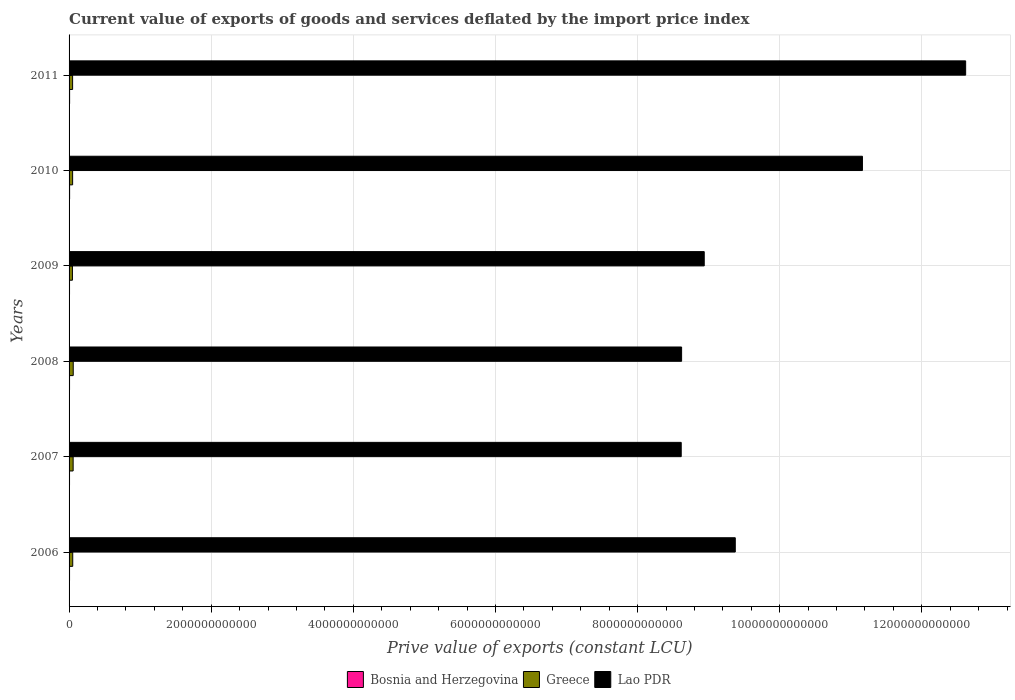How many different coloured bars are there?
Provide a short and direct response. 3. Are the number of bars on each tick of the Y-axis equal?
Offer a terse response. Yes. How many bars are there on the 6th tick from the bottom?
Offer a very short reply. 3. What is the label of the 6th group of bars from the top?
Your answer should be compact. 2006. What is the prive value of exports in Greece in 2011?
Your answer should be very brief. 4.97e+1. Across all years, what is the maximum prive value of exports in Greece?
Your answer should be compact. 5.86e+1. Across all years, what is the minimum prive value of exports in Lao PDR?
Offer a terse response. 8.61e+12. In which year was the prive value of exports in Bosnia and Herzegovina maximum?
Give a very brief answer. 2011. What is the total prive value of exports in Lao PDR in the graph?
Your answer should be compact. 5.93e+13. What is the difference between the prive value of exports in Lao PDR in 2006 and that in 2010?
Provide a succinct answer. -1.79e+12. What is the difference between the prive value of exports in Bosnia and Herzegovina in 2011 and the prive value of exports in Lao PDR in 2008?
Your answer should be very brief. -8.61e+12. What is the average prive value of exports in Lao PDR per year?
Provide a short and direct response. 9.89e+12. In the year 2011, what is the difference between the prive value of exports in Greece and prive value of exports in Lao PDR?
Provide a short and direct response. -1.26e+13. What is the ratio of the prive value of exports in Bosnia and Herzegovina in 2006 to that in 2011?
Offer a terse response. 0.87. Is the prive value of exports in Bosnia and Herzegovina in 2006 less than that in 2007?
Provide a succinct answer. No. Is the difference between the prive value of exports in Greece in 2008 and 2011 greater than the difference between the prive value of exports in Lao PDR in 2008 and 2011?
Give a very brief answer. Yes. What is the difference between the highest and the second highest prive value of exports in Bosnia and Herzegovina?
Keep it short and to the point. 1.52e+08. What is the difference between the highest and the lowest prive value of exports in Bosnia and Herzegovina?
Offer a terse response. 1.23e+09. In how many years, is the prive value of exports in Greece greater than the average prive value of exports in Greece taken over all years?
Your answer should be very brief. 2. Is the sum of the prive value of exports in Greece in 2008 and 2009 greater than the maximum prive value of exports in Lao PDR across all years?
Provide a short and direct response. No. What does the 3rd bar from the top in 2010 represents?
Make the answer very short. Bosnia and Herzegovina. What does the 2nd bar from the bottom in 2006 represents?
Provide a succinct answer. Greece. How many bars are there?
Offer a very short reply. 18. How many years are there in the graph?
Ensure brevity in your answer.  6. What is the difference between two consecutive major ticks on the X-axis?
Offer a very short reply. 2.00e+12. Are the values on the major ticks of X-axis written in scientific E-notation?
Your answer should be very brief. No. Does the graph contain any zero values?
Your answer should be very brief. No. Where does the legend appear in the graph?
Provide a short and direct response. Bottom center. How many legend labels are there?
Keep it short and to the point. 3. What is the title of the graph?
Your answer should be compact. Current value of exports of goods and services deflated by the import price index. What is the label or title of the X-axis?
Make the answer very short. Prive value of exports (constant LCU). What is the label or title of the Y-axis?
Your response must be concise. Years. What is the Prive value of exports (constant LCU) in Bosnia and Herzegovina in 2006?
Offer a very short reply. 6.66e+09. What is the Prive value of exports (constant LCU) of Greece in 2006?
Your answer should be compact. 5.16e+1. What is the Prive value of exports (constant LCU) in Lao PDR in 2006?
Keep it short and to the point. 9.37e+12. What is the Prive value of exports (constant LCU) in Bosnia and Herzegovina in 2007?
Provide a succinct answer. 6.46e+09. What is the Prive value of exports (constant LCU) in Greece in 2007?
Offer a terse response. 5.73e+1. What is the Prive value of exports (constant LCU) in Lao PDR in 2007?
Offer a very short reply. 8.61e+12. What is the Prive value of exports (constant LCU) of Bosnia and Herzegovina in 2008?
Ensure brevity in your answer.  6.71e+09. What is the Prive value of exports (constant LCU) in Greece in 2008?
Offer a very short reply. 5.86e+1. What is the Prive value of exports (constant LCU) in Lao PDR in 2008?
Provide a short and direct response. 8.62e+12. What is the Prive value of exports (constant LCU) in Bosnia and Herzegovina in 2009?
Give a very brief answer. 6.51e+09. What is the Prive value of exports (constant LCU) of Greece in 2009?
Offer a very short reply. 4.75e+1. What is the Prive value of exports (constant LCU) of Lao PDR in 2009?
Provide a short and direct response. 8.94e+12. What is the Prive value of exports (constant LCU) in Bosnia and Herzegovina in 2010?
Your answer should be very brief. 7.53e+09. What is the Prive value of exports (constant LCU) of Greece in 2010?
Offer a very short reply. 5.00e+1. What is the Prive value of exports (constant LCU) of Lao PDR in 2010?
Give a very brief answer. 1.12e+13. What is the Prive value of exports (constant LCU) in Bosnia and Herzegovina in 2011?
Make the answer very short. 7.68e+09. What is the Prive value of exports (constant LCU) in Greece in 2011?
Offer a very short reply. 4.97e+1. What is the Prive value of exports (constant LCU) in Lao PDR in 2011?
Your response must be concise. 1.26e+13. Across all years, what is the maximum Prive value of exports (constant LCU) in Bosnia and Herzegovina?
Provide a short and direct response. 7.68e+09. Across all years, what is the maximum Prive value of exports (constant LCU) of Greece?
Make the answer very short. 5.86e+1. Across all years, what is the maximum Prive value of exports (constant LCU) of Lao PDR?
Your answer should be very brief. 1.26e+13. Across all years, what is the minimum Prive value of exports (constant LCU) of Bosnia and Herzegovina?
Keep it short and to the point. 6.46e+09. Across all years, what is the minimum Prive value of exports (constant LCU) of Greece?
Your answer should be compact. 4.75e+1. Across all years, what is the minimum Prive value of exports (constant LCU) of Lao PDR?
Your answer should be compact. 8.61e+12. What is the total Prive value of exports (constant LCU) of Bosnia and Herzegovina in the graph?
Offer a very short reply. 4.16e+1. What is the total Prive value of exports (constant LCU) of Greece in the graph?
Your answer should be compact. 3.15e+11. What is the total Prive value of exports (constant LCU) of Lao PDR in the graph?
Your answer should be very brief. 5.93e+13. What is the difference between the Prive value of exports (constant LCU) in Bosnia and Herzegovina in 2006 and that in 2007?
Make the answer very short. 2.02e+08. What is the difference between the Prive value of exports (constant LCU) of Greece in 2006 and that in 2007?
Keep it short and to the point. -5.76e+09. What is the difference between the Prive value of exports (constant LCU) in Lao PDR in 2006 and that in 2007?
Provide a short and direct response. 7.61e+11. What is the difference between the Prive value of exports (constant LCU) of Bosnia and Herzegovina in 2006 and that in 2008?
Make the answer very short. -4.52e+07. What is the difference between the Prive value of exports (constant LCU) in Greece in 2006 and that in 2008?
Give a very brief answer. -7.07e+09. What is the difference between the Prive value of exports (constant LCU) of Lao PDR in 2006 and that in 2008?
Your response must be concise. 7.55e+11. What is the difference between the Prive value of exports (constant LCU) of Bosnia and Herzegovina in 2006 and that in 2009?
Your answer should be compact. 1.49e+08. What is the difference between the Prive value of exports (constant LCU) in Greece in 2006 and that in 2009?
Make the answer very short. 4.11e+09. What is the difference between the Prive value of exports (constant LCU) of Lao PDR in 2006 and that in 2009?
Provide a succinct answer. 4.37e+11. What is the difference between the Prive value of exports (constant LCU) of Bosnia and Herzegovina in 2006 and that in 2010?
Keep it short and to the point. -8.71e+08. What is the difference between the Prive value of exports (constant LCU) in Greece in 2006 and that in 2010?
Make the answer very short. 1.62e+09. What is the difference between the Prive value of exports (constant LCU) of Lao PDR in 2006 and that in 2010?
Keep it short and to the point. -1.79e+12. What is the difference between the Prive value of exports (constant LCU) in Bosnia and Herzegovina in 2006 and that in 2011?
Give a very brief answer. -1.02e+09. What is the difference between the Prive value of exports (constant LCU) in Greece in 2006 and that in 2011?
Keep it short and to the point. 1.87e+09. What is the difference between the Prive value of exports (constant LCU) of Lao PDR in 2006 and that in 2011?
Your answer should be very brief. -3.24e+12. What is the difference between the Prive value of exports (constant LCU) in Bosnia and Herzegovina in 2007 and that in 2008?
Offer a very short reply. -2.48e+08. What is the difference between the Prive value of exports (constant LCU) of Greece in 2007 and that in 2008?
Ensure brevity in your answer.  -1.31e+09. What is the difference between the Prive value of exports (constant LCU) of Lao PDR in 2007 and that in 2008?
Ensure brevity in your answer.  -5.55e+09. What is the difference between the Prive value of exports (constant LCU) of Bosnia and Herzegovina in 2007 and that in 2009?
Ensure brevity in your answer.  -5.35e+07. What is the difference between the Prive value of exports (constant LCU) of Greece in 2007 and that in 2009?
Give a very brief answer. 9.87e+09. What is the difference between the Prive value of exports (constant LCU) in Lao PDR in 2007 and that in 2009?
Your response must be concise. -3.24e+11. What is the difference between the Prive value of exports (constant LCU) in Bosnia and Herzegovina in 2007 and that in 2010?
Provide a short and direct response. -1.07e+09. What is the difference between the Prive value of exports (constant LCU) of Greece in 2007 and that in 2010?
Offer a terse response. 7.38e+09. What is the difference between the Prive value of exports (constant LCU) in Lao PDR in 2007 and that in 2010?
Provide a short and direct response. -2.55e+12. What is the difference between the Prive value of exports (constant LCU) in Bosnia and Herzegovina in 2007 and that in 2011?
Offer a terse response. -1.23e+09. What is the difference between the Prive value of exports (constant LCU) of Greece in 2007 and that in 2011?
Make the answer very short. 7.63e+09. What is the difference between the Prive value of exports (constant LCU) in Lao PDR in 2007 and that in 2011?
Ensure brevity in your answer.  -4.00e+12. What is the difference between the Prive value of exports (constant LCU) in Bosnia and Herzegovina in 2008 and that in 2009?
Make the answer very short. 1.94e+08. What is the difference between the Prive value of exports (constant LCU) in Greece in 2008 and that in 2009?
Give a very brief answer. 1.12e+1. What is the difference between the Prive value of exports (constant LCU) of Lao PDR in 2008 and that in 2009?
Make the answer very short. -3.18e+11. What is the difference between the Prive value of exports (constant LCU) in Bosnia and Herzegovina in 2008 and that in 2010?
Your response must be concise. -8.26e+08. What is the difference between the Prive value of exports (constant LCU) of Greece in 2008 and that in 2010?
Provide a succinct answer. 8.69e+09. What is the difference between the Prive value of exports (constant LCU) in Lao PDR in 2008 and that in 2010?
Your answer should be very brief. -2.54e+12. What is the difference between the Prive value of exports (constant LCU) of Bosnia and Herzegovina in 2008 and that in 2011?
Give a very brief answer. -9.78e+08. What is the difference between the Prive value of exports (constant LCU) of Greece in 2008 and that in 2011?
Offer a terse response. 8.95e+09. What is the difference between the Prive value of exports (constant LCU) of Lao PDR in 2008 and that in 2011?
Ensure brevity in your answer.  -4.00e+12. What is the difference between the Prive value of exports (constant LCU) in Bosnia and Herzegovina in 2009 and that in 2010?
Your response must be concise. -1.02e+09. What is the difference between the Prive value of exports (constant LCU) of Greece in 2009 and that in 2010?
Your answer should be compact. -2.49e+09. What is the difference between the Prive value of exports (constant LCU) in Lao PDR in 2009 and that in 2010?
Your answer should be very brief. -2.23e+12. What is the difference between the Prive value of exports (constant LCU) in Bosnia and Herzegovina in 2009 and that in 2011?
Offer a very short reply. -1.17e+09. What is the difference between the Prive value of exports (constant LCU) in Greece in 2009 and that in 2011?
Provide a succinct answer. -2.24e+09. What is the difference between the Prive value of exports (constant LCU) of Lao PDR in 2009 and that in 2011?
Make the answer very short. -3.68e+12. What is the difference between the Prive value of exports (constant LCU) of Bosnia and Herzegovina in 2010 and that in 2011?
Provide a short and direct response. -1.52e+08. What is the difference between the Prive value of exports (constant LCU) in Greece in 2010 and that in 2011?
Make the answer very short. 2.53e+08. What is the difference between the Prive value of exports (constant LCU) in Lao PDR in 2010 and that in 2011?
Ensure brevity in your answer.  -1.45e+12. What is the difference between the Prive value of exports (constant LCU) in Bosnia and Herzegovina in 2006 and the Prive value of exports (constant LCU) in Greece in 2007?
Keep it short and to the point. -5.07e+1. What is the difference between the Prive value of exports (constant LCU) of Bosnia and Herzegovina in 2006 and the Prive value of exports (constant LCU) of Lao PDR in 2007?
Ensure brevity in your answer.  -8.61e+12. What is the difference between the Prive value of exports (constant LCU) of Greece in 2006 and the Prive value of exports (constant LCU) of Lao PDR in 2007?
Provide a short and direct response. -8.56e+12. What is the difference between the Prive value of exports (constant LCU) in Bosnia and Herzegovina in 2006 and the Prive value of exports (constant LCU) in Greece in 2008?
Give a very brief answer. -5.20e+1. What is the difference between the Prive value of exports (constant LCU) in Bosnia and Herzegovina in 2006 and the Prive value of exports (constant LCU) in Lao PDR in 2008?
Your response must be concise. -8.61e+12. What is the difference between the Prive value of exports (constant LCU) of Greece in 2006 and the Prive value of exports (constant LCU) of Lao PDR in 2008?
Provide a succinct answer. -8.57e+12. What is the difference between the Prive value of exports (constant LCU) of Bosnia and Herzegovina in 2006 and the Prive value of exports (constant LCU) of Greece in 2009?
Make the answer very short. -4.08e+1. What is the difference between the Prive value of exports (constant LCU) of Bosnia and Herzegovina in 2006 and the Prive value of exports (constant LCU) of Lao PDR in 2009?
Provide a short and direct response. -8.93e+12. What is the difference between the Prive value of exports (constant LCU) of Greece in 2006 and the Prive value of exports (constant LCU) of Lao PDR in 2009?
Give a very brief answer. -8.89e+12. What is the difference between the Prive value of exports (constant LCU) in Bosnia and Herzegovina in 2006 and the Prive value of exports (constant LCU) in Greece in 2010?
Provide a short and direct response. -4.33e+1. What is the difference between the Prive value of exports (constant LCU) in Bosnia and Herzegovina in 2006 and the Prive value of exports (constant LCU) in Lao PDR in 2010?
Make the answer very short. -1.12e+13. What is the difference between the Prive value of exports (constant LCU) in Greece in 2006 and the Prive value of exports (constant LCU) in Lao PDR in 2010?
Offer a very short reply. -1.11e+13. What is the difference between the Prive value of exports (constant LCU) in Bosnia and Herzegovina in 2006 and the Prive value of exports (constant LCU) in Greece in 2011?
Your response must be concise. -4.30e+1. What is the difference between the Prive value of exports (constant LCU) of Bosnia and Herzegovina in 2006 and the Prive value of exports (constant LCU) of Lao PDR in 2011?
Your response must be concise. -1.26e+13. What is the difference between the Prive value of exports (constant LCU) of Greece in 2006 and the Prive value of exports (constant LCU) of Lao PDR in 2011?
Your answer should be compact. -1.26e+13. What is the difference between the Prive value of exports (constant LCU) in Bosnia and Herzegovina in 2007 and the Prive value of exports (constant LCU) in Greece in 2008?
Make the answer very short. -5.22e+1. What is the difference between the Prive value of exports (constant LCU) in Bosnia and Herzegovina in 2007 and the Prive value of exports (constant LCU) in Lao PDR in 2008?
Ensure brevity in your answer.  -8.61e+12. What is the difference between the Prive value of exports (constant LCU) in Greece in 2007 and the Prive value of exports (constant LCU) in Lao PDR in 2008?
Your response must be concise. -8.56e+12. What is the difference between the Prive value of exports (constant LCU) of Bosnia and Herzegovina in 2007 and the Prive value of exports (constant LCU) of Greece in 2009?
Provide a succinct answer. -4.10e+1. What is the difference between the Prive value of exports (constant LCU) in Bosnia and Herzegovina in 2007 and the Prive value of exports (constant LCU) in Lao PDR in 2009?
Keep it short and to the point. -8.93e+12. What is the difference between the Prive value of exports (constant LCU) in Greece in 2007 and the Prive value of exports (constant LCU) in Lao PDR in 2009?
Offer a very short reply. -8.88e+12. What is the difference between the Prive value of exports (constant LCU) in Bosnia and Herzegovina in 2007 and the Prive value of exports (constant LCU) in Greece in 2010?
Provide a short and direct response. -4.35e+1. What is the difference between the Prive value of exports (constant LCU) of Bosnia and Herzegovina in 2007 and the Prive value of exports (constant LCU) of Lao PDR in 2010?
Make the answer very short. -1.12e+13. What is the difference between the Prive value of exports (constant LCU) in Greece in 2007 and the Prive value of exports (constant LCU) in Lao PDR in 2010?
Provide a short and direct response. -1.11e+13. What is the difference between the Prive value of exports (constant LCU) in Bosnia and Herzegovina in 2007 and the Prive value of exports (constant LCU) in Greece in 2011?
Offer a terse response. -4.32e+1. What is the difference between the Prive value of exports (constant LCU) in Bosnia and Herzegovina in 2007 and the Prive value of exports (constant LCU) in Lao PDR in 2011?
Give a very brief answer. -1.26e+13. What is the difference between the Prive value of exports (constant LCU) of Greece in 2007 and the Prive value of exports (constant LCU) of Lao PDR in 2011?
Your answer should be very brief. -1.26e+13. What is the difference between the Prive value of exports (constant LCU) of Bosnia and Herzegovina in 2008 and the Prive value of exports (constant LCU) of Greece in 2009?
Provide a succinct answer. -4.08e+1. What is the difference between the Prive value of exports (constant LCU) of Bosnia and Herzegovina in 2008 and the Prive value of exports (constant LCU) of Lao PDR in 2009?
Keep it short and to the point. -8.93e+12. What is the difference between the Prive value of exports (constant LCU) of Greece in 2008 and the Prive value of exports (constant LCU) of Lao PDR in 2009?
Your answer should be compact. -8.88e+12. What is the difference between the Prive value of exports (constant LCU) in Bosnia and Herzegovina in 2008 and the Prive value of exports (constant LCU) in Greece in 2010?
Provide a succinct answer. -4.33e+1. What is the difference between the Prive value of exports (constant LCU) of Bosnia and Herzegovina in 2008 and the Prive value of exports (constant LCU) of Lao PDR in 2010?
Offer a terse response. -1.12e+13. What is the difference between the Prive value of exports (constant LCU) of Greece in 2008 and the Prive value of exports (constant LCU) of Lao PDR in 2010?
Your answer should be compact. -1.11e+13. What is the difference between the Prive value of exports (constant LCU) in Bosnia and Herzegovina in 2008 and the Prive value of exports (constant LCU) in Greece in 2011?
Your response must be concise. -4.30e+1. What is the difference between the Prive value of exports (constant LCU) of Bosnia and Herzegovina in 2008 and the Prive value of exports (constant LCU) of Lao PDR in 2011?
Offer a very short reply. -1.26e+13. What is the difference between the Prive value of exports (constant LCU) of Greece in 2008 and the Prive value of exports (constant LCU) of Lao PDR in 2011?
Offer a very short reply. -1.26e+13. What is the difference between the Prive value of exports (constant LCU) of Bosnia and Herzegovina in 2009 and the Prive value of exports (constant LCU) of Greece in 2010?
Keep it short and to the point. -4.34e+1. What is the difference between the Prive value of exports (constant LCU) of Bosnia and Herzegovina in 2009 and the Prive value of exports (constant LCU) of Lao PDR in 2010?
Offer a very short reply. -1.12e+13. What is the difference between the Prive value of exports (constant LCU) in Greece in 2009 and the Prive value of exports (constant LCU) in Lao PDR in 2010?
Offer a terse response. -1.11e+13. What is the difference between the Prive value of exports (constant LCU) of Bosnia and Herzegovina in 2009 and the Prive value of exports (constant LCU) of Greece in 2011?
Make the answer very short. -4.32e+1. What is the difference between the Prive value of exports (constant LCU) of Bosnia and Herzegovina in 2009 and the Prive value of exports (constant LCU) of Lao PDR in 2011?
Make the answer very short. -1.26e+13. What is the difference between the Prive value of exports (constant LCU) of Greece in 2009 and the Prive value of exports (constant LCU) of Lao PDR in 2011?
Make the answer very short. -1.26e+13. What is the difference between the Prive value of exports (constant LCU) in Bosnia and Herzegovina in 2010 and the Prive value of exports (constant LCU) in Greece in 2011?
Offer a terse response. -4.22e+1. What is the difference between the Prive value of exports (constant LCU) of Bosnia and Herzegovina in 2010 and the Prive value of exports (constant LCU) of Lao PDR in 2011?
Make the answer very short. -1.26e+13. What is the difference between the Prive value of exports (constant LCU) of Greece in 2010 and the Prive value of exports (constant LCU) of Lao PDR in 2011?
Offer a very short reply. -1.26e+13. What is the average Prive value of exports (constant LCU) in Bosnia and Herzegovina per year?
Keep it short and to the point. 6.93e+09. What is the average Prive value of exports (constant LCU) in Greece per year?
Your answer should be compact. 5.24e+1. What is the average Prive value of exports (constant LCU) in Lao PDR per year?
Keep it short and to the point. 9.89e+12. In the year 2006, what is the difference between the Prive value of exports (constant LCU) in Bosnia and Herzegovina and Prive value of exports (constant LCU) in Greece?
Ensure brevity in your answer.  -4.49e+1. In the year 2006, what is the difference between the Prive value of exports (constant LCU) in Bosnia and Herzegovina and Prive value of exports (constant LCU) in Lao PDR?
Your response must be concise. -9.37e+12. In the year 2006, what is the difference between the Prive value of exports (constant LCU) of Greece and Prive value of exports (constant LCU) of Lao PDR?
Provide a short and direct response. -9.32e+12. In the year 2007, what is the difference between the Prive value of exports (constant LCU) in Bosnia and Herzegovina and Prive value of exports (constant LCU) in Greece?
Make the answer very short. -5.09e+1. In the year 2007, what is the difference between the Prive value of exports (constant LCU) of Bosnia and Herzegovina and Prive value of exports (constant LCU) of Lao PDR?
Keep it short and to the point. -8.61e+12. In the year 2007, what is the difference between the Prive value of exports (constant LCU) in Greece and Prive value of exports (constant LCU) in Lao PDR?
Provide a short and direct response. -8.56e+12. In the year 2008, what is the difference between the Prive value of exports (constant LCU) in Bosnia and Herzegovina and Prive value of exports (constant LCU) in Greece?
Your response must be concise. -5.19e+1. In the year 2008, what is the difference between the Prive value of exports (constant LCU) in Bosnia and Herzegovina and Prive value of exports (constant LCU) in Lao PDR?
Keep it short and to the point. -8.61e+12. In the year 2008, what is the difference between the Prive value of exports (constant LCU) of Greece and Prive value of exports (constant LCU) of Lao PDR?
Offer a very short reply. -8.56e+12. In the year 2009, what is the difference between the Prive value of exports (constant LCU) of Bosnia and Herzegovina and Prive value of exports (constant LCU) of Greece?
Offer a terse response. -4.10e+1. In the year 2009, what is the difference between the Prive value of exports (constant LCU) in Bosnia and Herzegovina and Prive value of exports (constant LCU) in Lao PDR?
Offer a very short reply. -8.93e+12. In the year 2009, what is the difference between the Prive value of exports (constant LCU) of Greece and Prive value of exports (constant LCU) of Lao PDR?
Your answer should be very brief. -8.89e+12. In the year 2010, what is the difference between the Prive value of exports (constant LCU) in Bosnia and Herzegovina and Prive value of exports (constant LCU) in Greece?
Ensure brevity in your answer.  -4.24e+1. In the year 2010, what is the difference between the Prive value of exports (constant LCU) of Bosnia and Herzegovina and Prive value of exports (constant LCU) of Lao PDR?
Offer a terse response. -1.12e+13. In the year 2010, what is the difference between the Prive value of exports (constant LCU) of Greece and Prive value of exports (constant LCU) of Lao PDR?
Provide a short and direct response. -1.11e+13. In the year 2011, what is the difference between the Prive value of exports (constant LCU) in Bosnia and Herzegovina and Prive value of exports (constant LCU) in Greece?
Provide a short and direct response. -4.20e+1. In the year 2011, what is the difference between the Prive value of exports (constant LCU) of Bosnia and Herzegovina and Prive value of exports (constant LCU) of Lao PDR?
Your answer should be compact. -1.26e+13. In the year 2011, what is the difference between the Prive value of exports (constant LCU) in Greece and Prive value of exports (constant LCU) in Lao PDR?
Offer a terse response. -1.26e+13. What is the ratio of the Prive value of exports (constant LCU) of Bosnia and Herzegovina in 2006 to that in 2007?
Offer a terse response. 1.03. What is the ratio of the Prive value of exports (constant LCU) of Greece in 2006 to that in 2007?
Your answer should be very brief. 0.9. What is the ratio of the Prive value of exports (constant LCU) in Lao PDR in 2006 to that in 2007?
Offer a terse response. 1.09. What is the ratio of the Prive value of exports (constant LCU) in Greece in 2006 to that in 2008?
Make the answer very short. 0.88. What is the ratio of the Prive value of exports (constant LCU) in Lao PDR in 2006 to that in 2008?
Your answer should be compact. 1.09. What is the ratio of the Prive value of exports (constant LCU) of Bosnia and Herzegovina in 2006 to that in 2009?
Your response must be concise. 1.02. What is the ratio of the Prive value of exports (constant LCU) in Greece in 2006 to that in 2009?
Keep it short and to the point. 1.09. What is the ratio of the Prive value of exports (constant LCU) in Lao PDR in 2006 to that in 2009?
Your answer should be compact. 1.05. What is the ratio of the Prive value of exports (constant LCU) of Bosnia and Herzegovina in 2006 to that in 2010?
Keep it short and to the point. 0.88. What is the ratio of the Prive value of exports (constant LCU) in Greece in 2006 to that in 2010?
Provide a short and direct response. 1.03. What is the ratio of the Prive value of exports (constant LCU) of Lao PDR in 2006 to that in 2010?
Make the answer very short. 0.84. What is the ratio of the Prive value of exports (constant LCU) in Bosnia and Herzegovina in 2006 to that in 2011?
Your answer should be very brief. 0.87. What is the ratio of the Prive value of exports (constant LCU) of Greece in 2006 to that in 2011?
Provide a succinct answer. 1.04. What is the ratio of the Prive value of exports (constant LCU) in Lao PDR in 2006 to that in 2011?
Offer a terse response. 0.74. What is the ratio of the Prive value of exports (constant LCU) in Bosnia and Herzegovina in 2007 to that in 2008?
Offer a very short reply. 0.96. What is the ratio of the Prive value of exports (constant LCU) of Greece in 2007 to that in 2008?
Your response must be concise. 0.98. What is the ratio of the Prive value of exports (constant LCU) in Lao PDR in 2007 to that in 2008?
Keep it short and to the point. 1. What is the ratio of the Prive value of exports (constant LCU) of Greece in 2007 to that in 2009?
Provide a succinct answer. 1.21. What is the ratio of the Prive value of exports (constant LCU) of Lao PDR in 2007 to that in 2009?
Your response must be concise. 0.96. What is the ratio of the Prive value of exports (constant LCU) of Bosnia and Herzegovina in 2007 to that in 2010?
Make the answer very short. 0.86. What is the ratio of the Prive value of exports (constant LCU) of Greece in 2007 to that in 2010?
Your answer should be very brief. 1.15. What is the ratio of the Prive value of exports (constant LCU) of Lao PDR in 2007 to that in 2010?
Provide a short and direct response. 0.77. What is the ratio of the Prive value of exports (constant LCU) of Bosnia and Herzegovina in 2007 to that in 2011?
Keep it short and to the point. 0.84. What is the ratio of the Prive value of exports (constant LCU) of Greece in 2007 to that in 2011?
Provide a succinct answer. 1.15. What is the ratio of the Prive value of exports (constant LCU) of Lao PDR in 2007 to that in 2011?
Ensure brevity in your answer.  0.68. What is the ratio of the Prive value of exports (constant LCU) in Bosnia and Herzegovina in 2008 to that in 2009?
Ensure brevity in your answer.  1.03. What is the ratio of the Prive value of exports (constant LCU) of Greece in 2008 to that in 2009?
Offer a terse response. 1.24. What is the ratio of the Prive value of exports (constant LCU) of Lao PDR in 2008 to that in 2009?
Keep it short and to the point. 0.96. What is the ratio of the Prive value of exports (constant LCU) in Bosnia and Herzegovina in 2008 to that in 2010?
Make the answer very short. 0.89. What is the ratio of the Prive value of exports (constant LCU) of Greece in 2008 to that in 2010?
Your answer should be compact. 1.17. What is the ratio of the Prive value of exports (constant LCU) in Lao PDR in 2008 to that in 2010?
Ensure brevity in your answer.  0.77. What is the ratio of the Prive value of exports (constant LCU) of Bosnia and Herzegovina in 2008 to that in 2011?
Provide a short and direct response. 0.87. What is the ratio of the Prive value of exports (constant LCU) in Greece in 2008 to that in 2011?
Keep it short and to the point. 1.18. What is the ratio of the Prive value of exports (constant LCU) in Lao PDR in 2008 to that in 2011?
Offer a very short reply. 0.68. What is the ratio of the Prive value of exports (constant LCU) of Bosnia and Herzegovina in 2009 to that in 2010?
Give a very brief answer. 0.86. What is the ratio of the Prive value of exports (constant LCU) in Greece in 2009 to that in 2010?
Provide a short and direct response. 0.95. What is the ratio of the Prive value of exports (constant LCU) in Lao PDR in 2009 to that in 2010?
Offer a very short reply. 0.8. What is the ratio of the Prive value of exports (constant LCU) in Bosnia and Herzegovina in 2009 to that in 2011?
Keep it short and to the point. 0.85. What is the ratio of the Prive value of exports (constant LCU) in Greece in 2009 to that in 2011?
Your response must be concise. 0.95. What is the ratio of the Prive value of exports (constant LCU) of Lao PDR in 2009 to that in 2011?
Offer a terse response. 0.71. What is the ratio of the Prive value of exports (constant LCU) of Bosnia and Herzegovina in 2010 to that in 2011?
Make the answer very short. 0.98. What is the ratio of the Prive value of exports (constant LCU) in Lao PDR in 2010 to that in 2011?
Your response must be concise. 0.88. What is the difference between the highest and the second highest Prive value of exports (constant LCU) in Bosnia and Herzegovina?
Keep it short and to the point. 1.52e+08. What is the difference between the highest and the second highest Prive value of exports (constant LCU) of Greece?
Your answer should be compact. 1.31e+09. What is the difference between the highest and the second highest Prive value of exports (constant LCU) of Lao PDR?
Keep it short and to the point. 1.45e+12. What is the difference between the highest and the lowest Prive value of exports (constant LCU) of Bosnia and Herzegovina?
Offer a very short reply. 1.23e+09. What is the difference between the highest and the lowest Prive value of exports (constant LCU) in Greece?
Offer a very short reply. 1.12e+1. What is the difference between the highest and the lowest Prive value of exports (constant LCU) in Lao PDR?
Provide a succinct answer. 4.00e+12. 